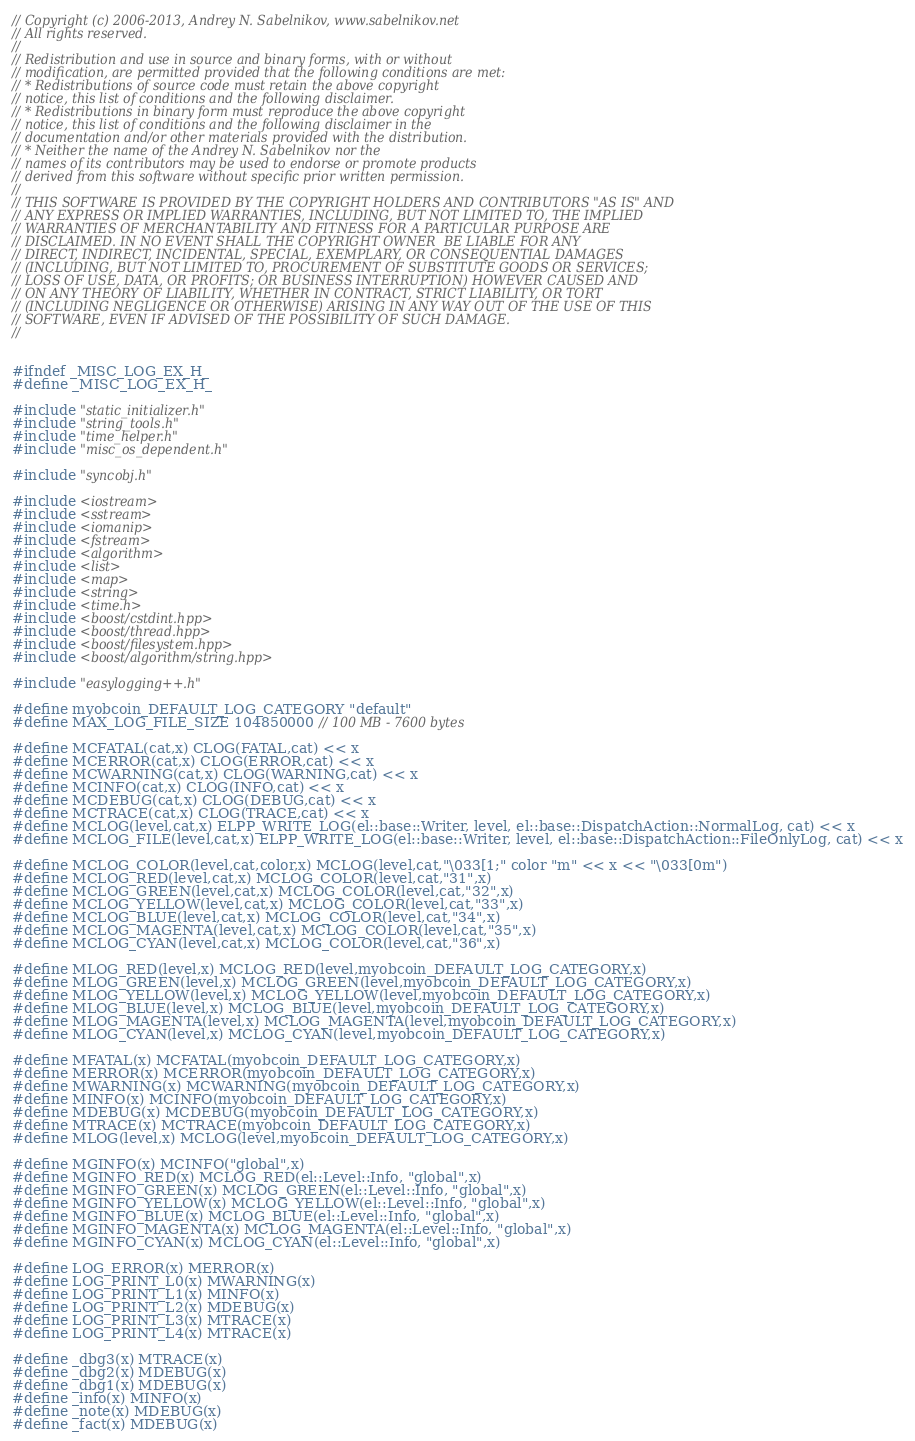Convert code to text. <code><loc_0><loc_0><loc_500><loc_500><_C_>// Copyright (c) 2006-2013, Andrey N. Sabelnikov, www.sabelnikov.net
// All rights reserved.
//
// Redistribution and use in source and binary forms, with or without
// modification, are permitted provided that the following conditions are met:
// * Redistributions of source code must retain the above copyright
// notice, this list of conditions and the following disclaimer.
// * Redistributions in binary form must reproduce the above copyright
// notice, this list of conditions and the following disclaimer in the
// documentation and/or other materials provided with the distribution.
// * Neither the name of the Andrey N. Sabelnikov nor the
// names of its contributors may be used to endorse or promote products
// derived from this software without specific prior written permission.
//
// THIS SOFTWARE IS PROVIDED BY THE COPYRIGHT HOLDERS AND CONTRIBUTORS "AS IS" AND
// ANY EXPRESS OR IMPLIED WARRANTIES, INCLUDING, BUT NOT LIMITED TO, THE IMPLIED
// WARRANTIES OF MERCHANTABILITY AND FITNESS FOR A PARTICULAR PURPOSE ARE
// DISCLAIMED. IN NO EVENT SHALL THE COPYRIGHT OWNER  BE LIABLE FOR ANY
// DIRECT, INDIRECT, INCIDENTAL, SPECIAL, EXEMPLARY, OR CONSEQUENTIAL DAMAGES
// (INCLUDING, BUT NOT LIMITED TO, PROCUREMENT OF SUBSTITUTE GOODS OR SERVICES;
// LOSS OF USE, DATA, OR PROFITS; OR BUSINESS INTERRUPTION) HOWEVER CAUSED AND
// ON ANY THEORY OF LIABILITY, WHETHER IN CONTRACT, STRICT LIABILITY, OR TORT
// (INCLUDING NEGLIGENCE OR OTHERWISE) ARISING IN ANY WAY OUT OF THE USE OF THIS
// SOFTWARE, EVEN IF ADVISED OF THE POSSIBILITY OF SUCH DAMAGE.
//


#ifndef _MISC_LOG_EX_H_
#define _MISC_LOG_EX_H_

#include "static_initializer.h"
#include "string_tools.h"
#include "time_helper.h"
#include "misc_os_dependent.h"

#include "syncobj.h"

#include <iostream>
#include <sstream>
#include <iomanip>
#include <fstream>
#include <algorithm>
#include <list>
#include <map>
#include <string>
#include <time.h>
#include <boost/cstdint.hpp>
#include <boost/thread.hpp>
#include <boost/filesystem.hpp>
#include <boost/algorithm/string.hpp>

#include "easylogging++.h"

#define myobcoin_DEFAULT_LOG_CATEGORY "default"
#define MAX_LOG_FILE_SIZE 104850000 // 100 MB - 7600 bytes

#define MCFATAL(cat,x) CLOG(FATAL,cat) << x
#define MCERROR(cat,x) CLOG(ERROR,cat) << x
#define MCWARNING(cat,x) CLOG(WARNING,cat) << x
#define MCINFO(cat,x) CLOG(INFO,cat) << x
#define MCDEBUG(cat,x) CLOG(DEBUG,cat) << x
#define MCTRACE(cat,x) CLOG(TRACE,cat) << x
#define MCLOG(level,cat,x) ELPP_WRITE_LOG(el::base::Writer, level, el::base::DispatchAction::NormalLog, cat) << x
#define MCLOG_FILE(level,cat,x) ELPP_WRITE_LOG(el::base::Writer, level, el::base::DispatchAction::FileOnlyLog, cat) << x

#define MCLOG_COLOR(level,cat,color,x) MCLOG(level,cat,"\033[1;" color "m" << x << "\033[0m")
#define MCLOG_RED(level,cat,x) MCLOG_COLOR(level,cat,"31",x)
#define MCLOG_GREEN(level,cat,x) MCLOG_COLOR(level,cat,"32",x)
#define MCLOG_YELLOW(level,cat,x) MCLOG_COLOR(level,cat,"33",x)
#define MCLOG_BLUE(level,cat,x) MCLOG_COLOR(level,cat,"34",x)
#define MCLOG_MAGENTA(level,cat,x) MCLOG_COLOR(level,cat,"35",x)
#define MCLOG_CYAN(level,cat,x) MCLOG_COLOR(level,cat,"36",x)

#define MLOG_RED(level,x) MCLOG_RED(level,myobcoin_DEFAULT_LOG_CATEGORY,x)
#define MLOG_GREEN(level,x) MCLOG_GREEN(level,myobcoin_DEFAULT_LOG_CATEGORY,x)
#define MLOG_YELLOW(level,x) MCLOG_YELLOW(level,myobcoin_DEFAULT_LOG_CATEGORY,x)
#define MLOG_BLUE(level,x) MCLOG_BLUE(level,myobcoin_DEFAULT_LOG_CATEGORY,x)
#define MLOG_MAGENTA(level,x) MCLOG_MAGENTA(level,myobcoin_DEFAULT_LOG_CATEGORY,x)
#define MLOG_CYAN(level,x) MCLOG_CYAN(level,myobcoin_DEFAULT_LOG_CATEGORY,x)

#define MFATAL(x) MCFATAL(myobcoin_DEFAULT_LOG_CATEGORY,x)
#define MERROR(x) MCERROR(myobcoin_DEFAULT_LOG_CATEGORY,x)
#define MWARNING(x) MCWARNING(myobcoin_DEFAULT_LOG_CATEGORY,x)
#define MINFO(x) MCINFO(myobcoin_DEFAULT_LOG_CATEGORY,x)
#define MDEBUG(x) MCDEBUG(myobcoin_DEFAULT_LOG_CATEGORY,x)
#define MTRACE(x) MCTRACE(myobcoin_DEFAULT_LOG_CATEGORY,x)
#define MLOG(level,x) MCLOG(level,myobcoin_DEFAULT_LOG_CATEGORY,x)

#define MGINFO(x) MCINFO("global",x)
#define MGINFO_RED(x) MCLOG_RED(el::Level::Info, "global",x)
#define MGINFO_GREEN(x) MCLOG_GREEN(el::Level::Info, "global",x)
#define MGINFO_YELLOW(x) MCLOG_YELLOW(el::Level::Info, "global",x)
#define MGINFO_BLUE(x) MCLOG_BLUE(el::Level::Info, "global",x)
#define MGINFO_MAGENTA(x) MCLOG_MAGENTA(el::Level::Info, "global",x)
#define MGINFO_CYAN(x) MCLOG_CYAN(el::Level::Info, "global",x)

#define LOG_ERROR(x) MERROR(x)
#define LOG_PRINT_L0(x) MWARNING(x)
#define LOG_PRINT_L1(x) MINFO(x)
#define LOG_PRINT_L2(x) MDEBUG(x)
#define LOG_PRINT_L3(x) MTRACE(x)
#define LOG_PRINT_L4(x) MTRACE(x)

#define _dbg3(x) MTRACE(x)
#define _dbg2(x) MDEBUG(x)
#define _dbg1(x) MDEBUG(x)
#define _info(x) MINFO(x)
#define _note(x) MDEBUG(x)
#define _fact(x) MDEBUG(x)</code> 